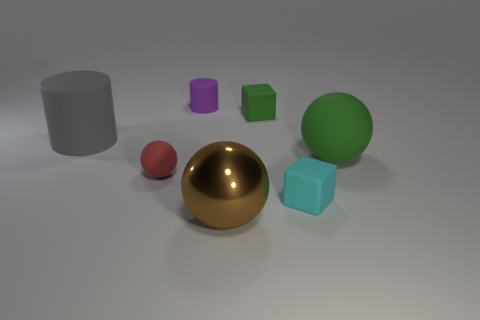Subtract all brown metallic spheres. How many spheres are left? 2 Subtract 2 spheres. How many spheres are left? 1 Subtract all red blocks. Subtract all yellow balls. How many blocks are left? 2 Subtract all yellow cylinders. How many cyan blocks are left? 1 Subtract all big gray cylinders. Subtract all small balls. How many objects are left? 5 Add 6 large matte objects. How many large matte objects are left? 8 Add 4 large red spheres. How many large red spheres exist? 4 Add 1 small green cylinders. How many objects exist? 8 Subtract all brown balls. How many balls are left? 2 Subtract 0 green cylinders. How many objects are left? 7 